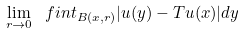Convert formula to latex. <formula><loc_0><loc_0><loc_500><loc_500>\lim _ { r \to 0 } \ f i n t _ { B ( x , r ) } | u ( y ) - T u ( x ) | d y</formula> 